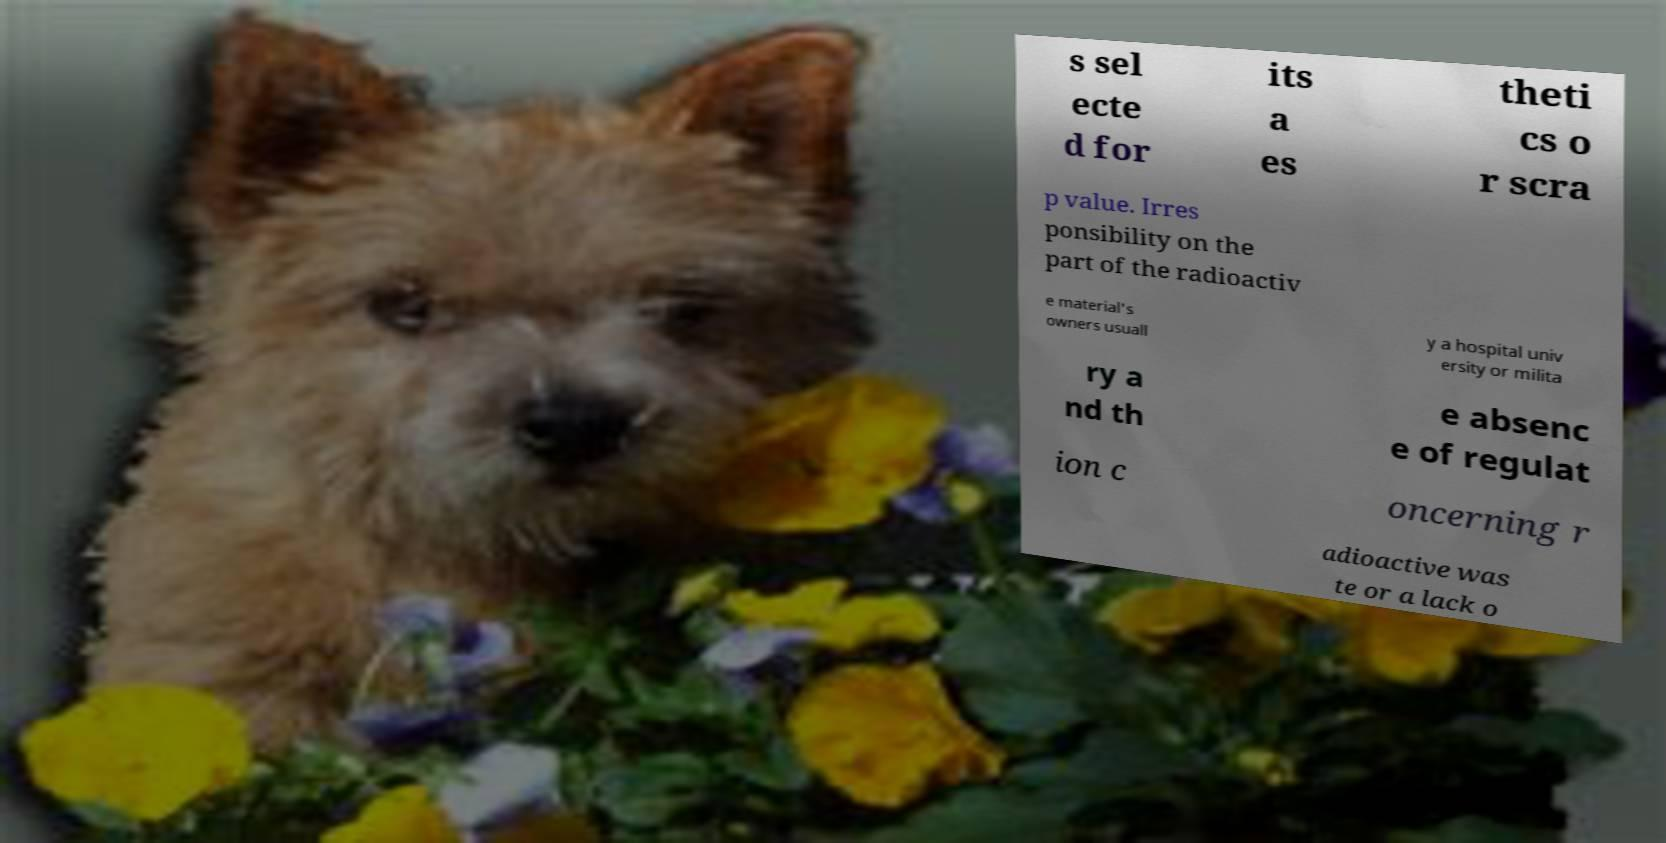Could you extract and type out the text from this image? s sel ecte d for its a es theti cs o r scra p value. Irres ponsibility on the part of the radioactiv e material's owners usuall y a hospital univ ersity or milita ry a nd th e absenc e of regulat ion c oncerning r adioactive was te or a lack o 